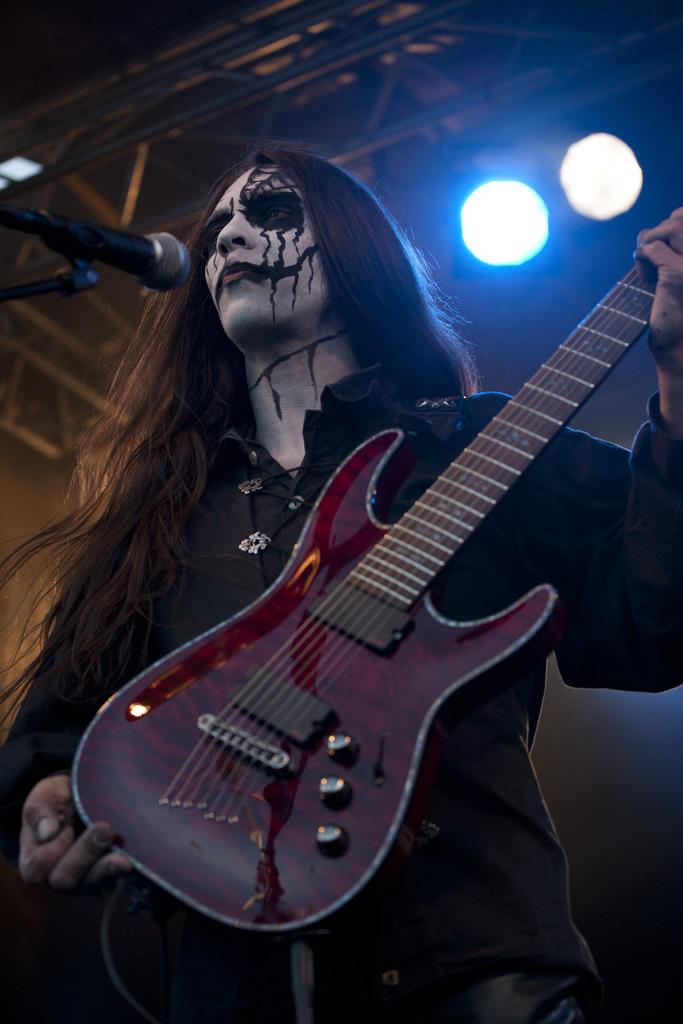What is the main subject of the image? There is a person in the image. What is the person holding in the image? The person is holding a guitar. Where is the guitar located in the image? The guitar is in the middle of the image. What can be seen in the background of the image? There are two lights in the background of the image. How much payment is the person receiving for playing the guitar in the image? There is no indication of payment in the image; it only shows a person holding a guitar. 